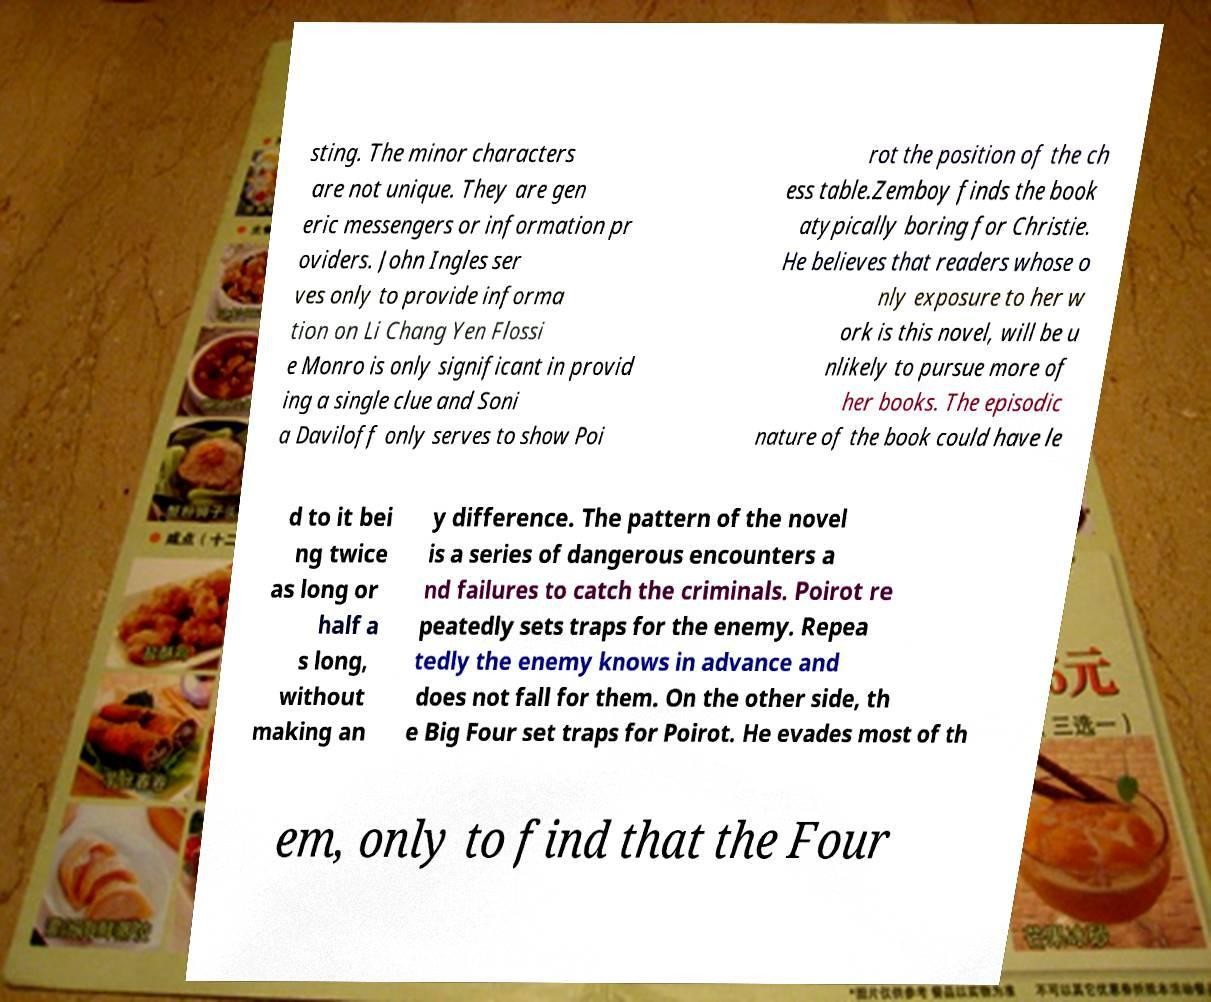I need the written content from this picture converted into text. Can you do that? sting. The minor characters are not unique. They are gen eric messengers or information pr oviders. John Ingles ser ves only to provide informa tion on Li Chang Yen Flossi e Monro is only significant in provid ing a single clue and Soni a Daviloff only serves to show Poi rot the position of the ch ess table.Zemboy finds the book atypically boring for Christie. He believes that readers whose o nly exposure to her w ork is this novel, will be u nlikely to pursue more of her books. The episodic nature of the book could have le d to it bei ng twice as long or half a s long, without making an y difference. The pattern of the novel is a series of dangerous encounters a nd failures to catch the criminals. Poirot re peatedly sets traps for the enemy. Repea tedly the enemy knows in advance and does not fall for them. On the other side, th e Big Four set traps for Poirot. He evades most of th em, only to find that the Four 